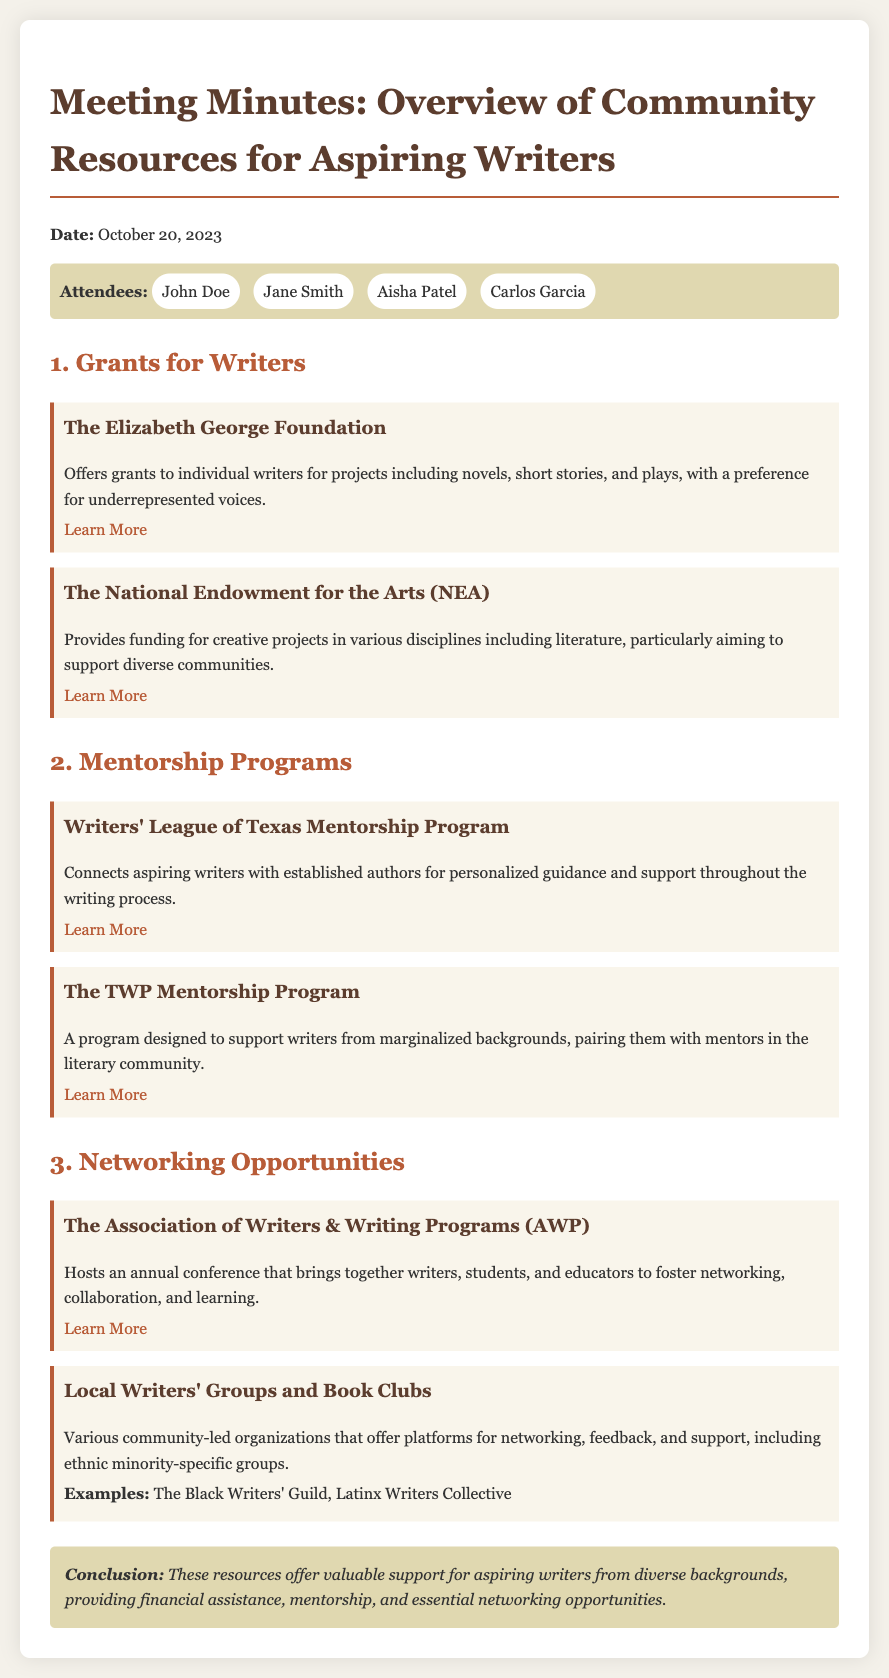What is the date of the meeting? The date of the meeting is stated at the beginning of the document.
Answer: October 20, 2023 Who attended the meeting? The attendees are listed in the document under the attendees section.
Answer: John Doe, Jane Smith, Aisha Patel, Carlos Garcia Which foundation offers grants with a preference for underrepresented voices? This information is found under the grants section of the document.
Answer: The Elizabeth George Foundation What is the focus of The TWP Mentorship Program? The focus of this program is mentioned in the description provided in the mentorship programs section.
Answer: Writers from marginalized backgrounds What does AWP stand for? The acronym is mentioned in the networking opportunities section of the document.
Answer: The Association of Writers & Writing Programs How many grants are listed in the meeting minutes? This requires counting the grant resources mentioned in the grants section of the document.
Answer: Two Which organization hosts an annual conference? The document specifies an organization that hosts an annual event in the networking opportunities section.
Answer: AWP What type of groups are mentioned for networking opportunities? This is detailed in the local writers' groups and book clubs section of the networking opportunities.
Answer: Community-led organizations What is the main conclusion of the meeting? The conclusion summarizes the outcomes of the meeting and is found in the conclusion section.
Answer: Valuable support for aspiring writers from diverse backgrounds 